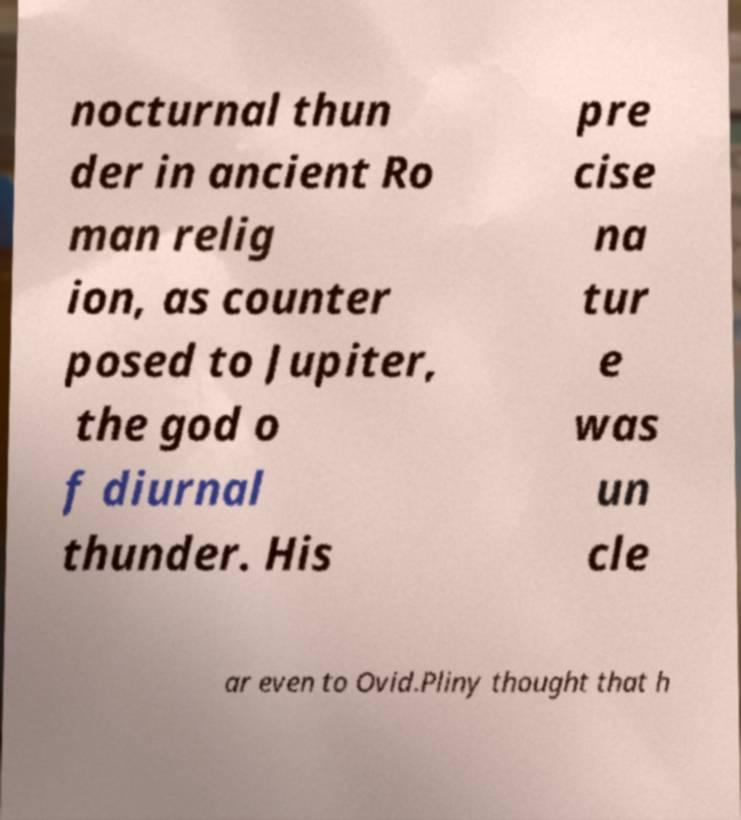For documentation purposes, I need the text within this image transcribed. Could you provide that? nocturnal thun der in ancient Ro man relig ion, as counter posed to Jupiter, the god o f diurnal thunder. His pre cise na tur e was un cle ar even to Ovid.Pliny thought that h 